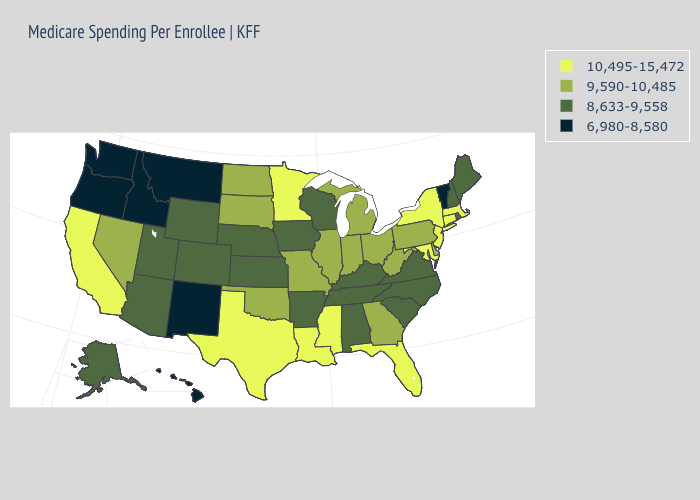What is the highest value in the USA?
Be succinct. 10,495-15,472. What is the highest value in the USA?
Write a very short answer. 10,495-15,472. Name the states that have a value in the range 8,633-9,558?
Concise answer only. Alabama, Alaska, Arizona, Arkansas, Colorado, Iowa, Kansas, Kentucky, Maine, Nebraska, New Hampshire, North Carolina, Rhode Island, South Carolina, Tennessee, Utah, Virginia, Wisconsin, Wyoming. Name the states that have a value in the range 10,495-15,472?
Keep it brief. California, Connecticut, Florida, Louisiana, Maryland, Massachusetts, Minnesota, Mississippi, New Jersey, New York, Texas. What is the value of Louisiana?
Be succinct. 10,495-15,472. Does Washington have the lowest value in the USA?
Concise answer only. Yes. Among the states that border Utah , which have the lowest value?
Answer briefly. Idaho, New Mexico. Does the map have missing data?
Concise answer only. No. Which states have the highest value in the USA?
Write a very short answer. California, Connecticut, Florida, Louisiana, Maryland, Massachusetts, Minnesota, Mississippi, New Jersey, New York, Texas. Which states hav the highest value in the MidWest?
Write a very short answer. Minnesota. What is the value of Missouri?
Answer briefly. 9,590-10,485. Name the states that have a value in the range 10,495-15,472?
Keep it brief. California, Connecticut, Florida, Louisiana, Maryland, Massachusetts, Minnesota, Mississippi, New Jersey, New York, Texas. What is the value of Minnesota?
Write a very short answer. 10,495-15,472. Name the states that have a value in the range 10,495-15,472?
Be succinct. California, Connecticut, Florida, Louisiana, Maryland, Massachusetts, Minnesota, Mississippi, New Jersey, New York, Texas. What is the highest value in states that border New Jersey?
Be succinct. 10,495-15,472. 